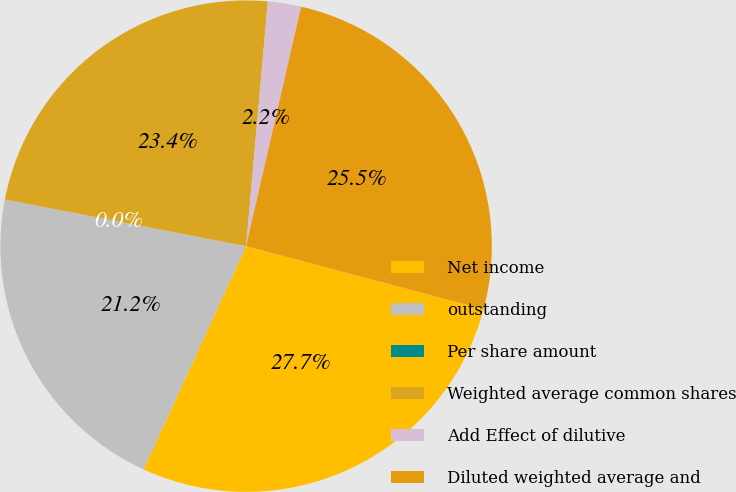Convert chart to OTSL. <chart><loc_0><loc_0><loc_500><loc_500><pie_chart><fcel>Net income<fcel>outstanding<fcel>Per share amount<fcel>Weighted average common shares<fcel>Add Effect of dilutive<fcel>Diluted weighted average and<nl><fcel>27.72%<fcel>21.19%<fcel>0.0%<fcel>23.37%<fcel>2.18%<fcel>25.54%<nl></chart> 